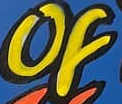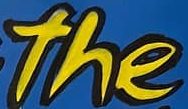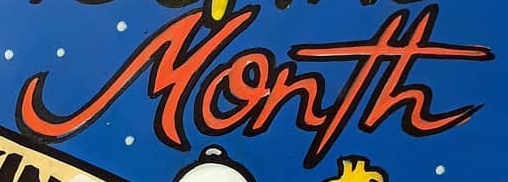What words are shown in these images in order, separated by a semicolon? of; the; Month 